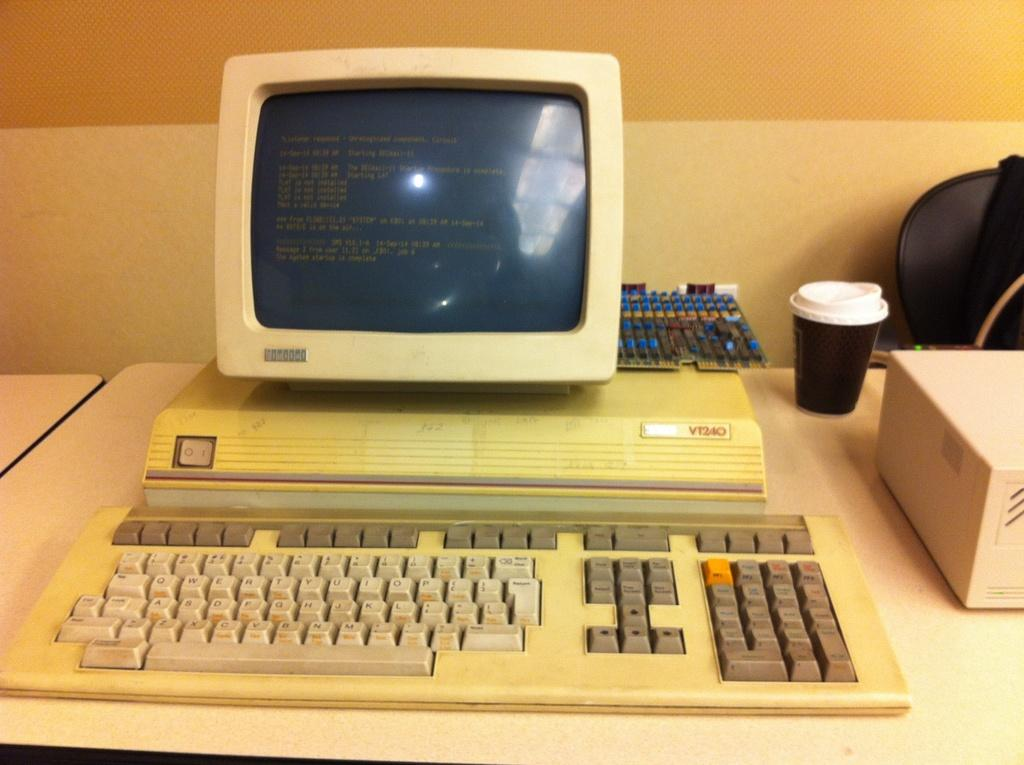Provide a one-sentence caption for the provided image. A very old VT240 screen and keyboard sits on a desk. 